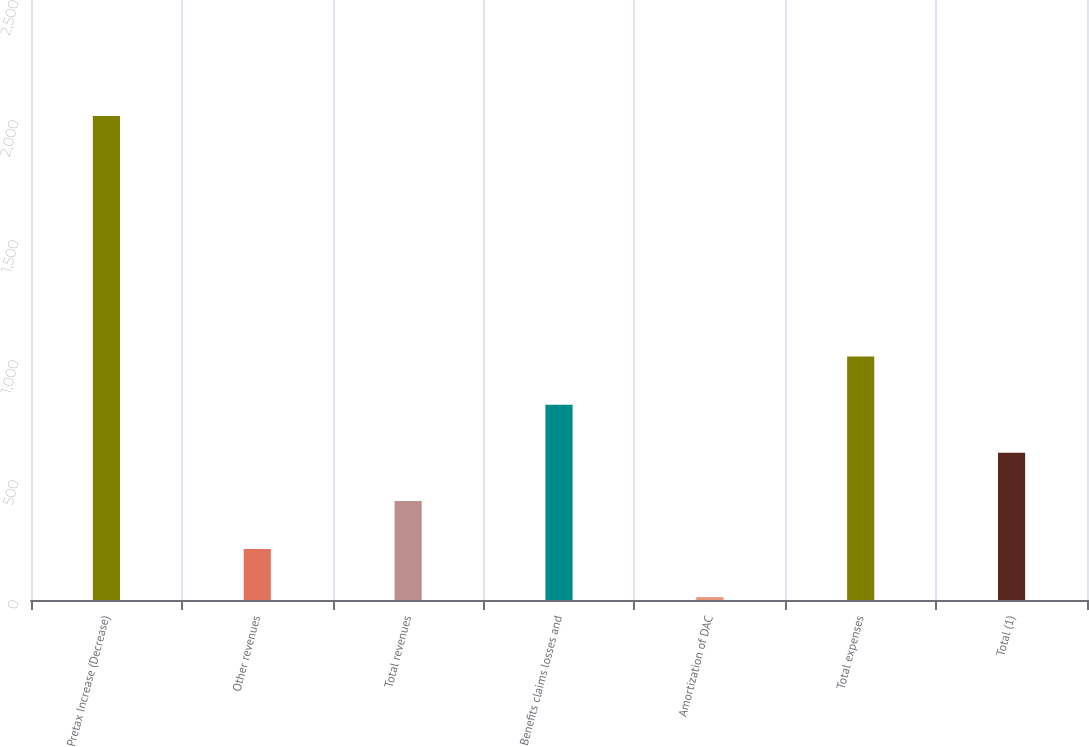<chart> <loc_0><loc_0><loc_500><loc_500><bar_chart><fcel>Pretax Increase (Decrease)<fcel>Other revenues<fcel>Total revenues<fcel>Benefits claims losses and<fcel>Amortization of DAC<fcel>Total expenses<fcel>Total (1)<nl><fcel>2017<fcel>212.5<fcel>413<fcel>814<fcel>12<fcel>1014.5<fcel>613.5<nl></chart> 